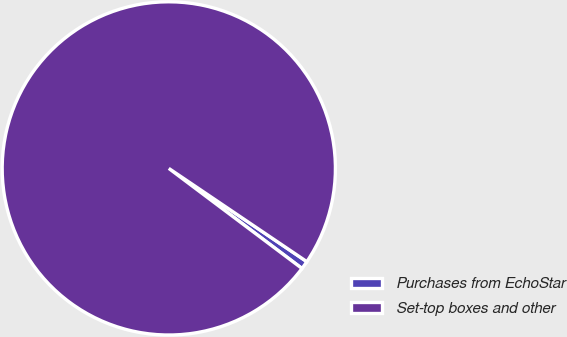<chart> <loc_0><loc_0><loc_500><loc_500><pie_chart><fcel>Purchases from EchoStar<fcel>Set-top boxes and other<nl><fcel>0.8%<fcel>99.2%<nl></chart> 